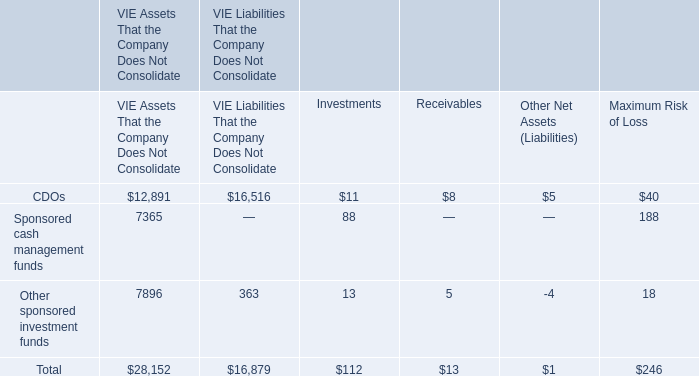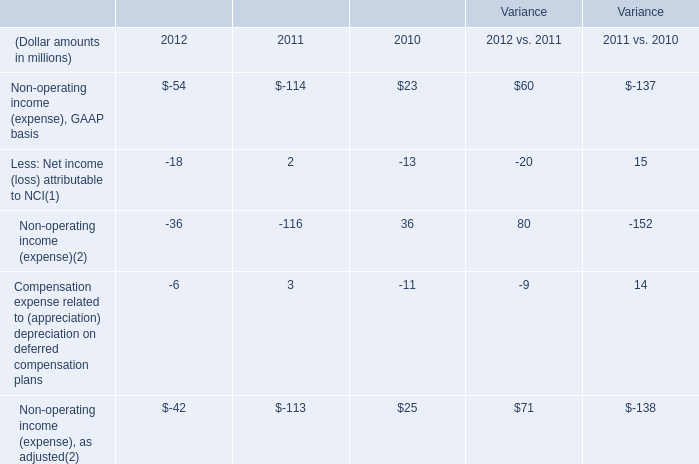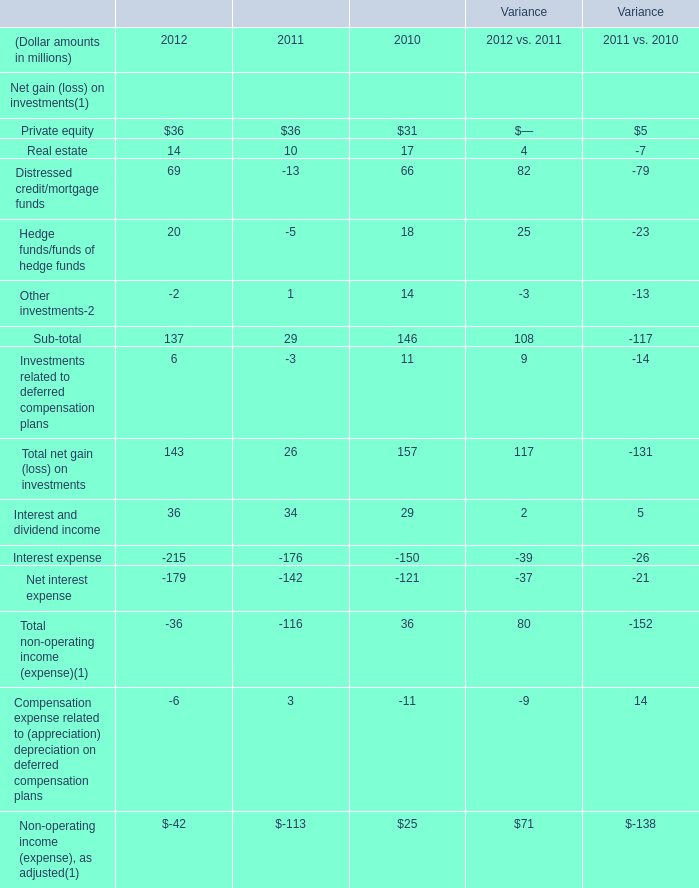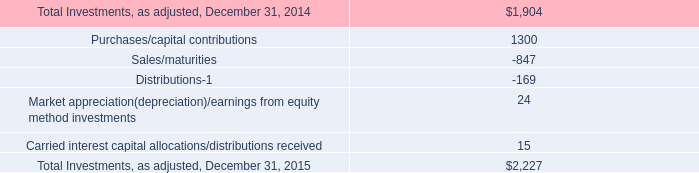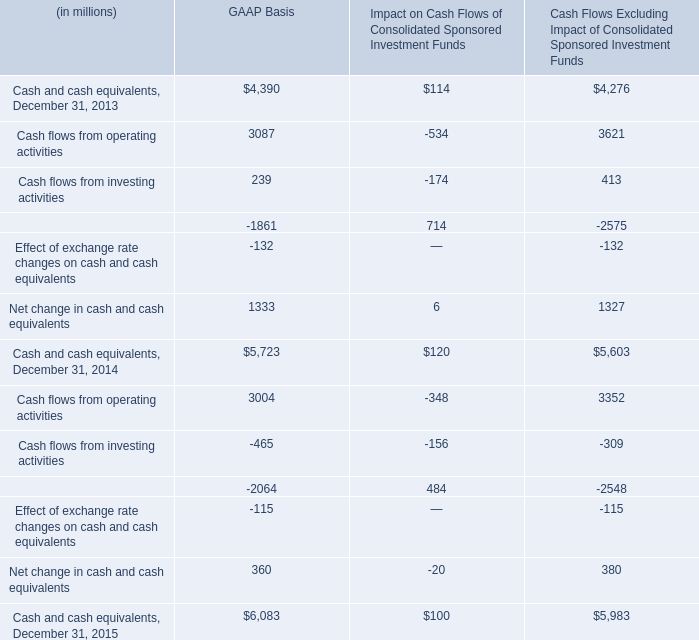What was the average of the Non-operating income (expense) in the years where Non-operating income (expense), GAAP basis is positive? (in million) 
Computations: ((36 + 80) / 2)
Answer: 58.0. 